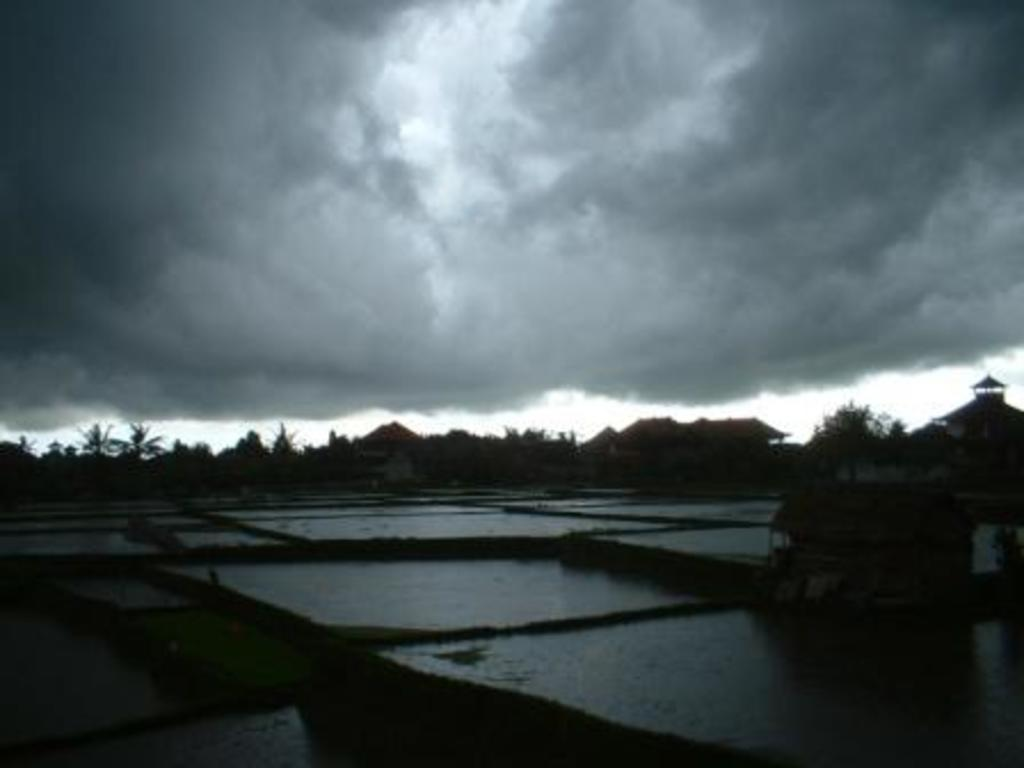What is present in the front of the image? There is water in the front of the image. What can be seen in the image besides the water? There is an object visible in the image. What type of vegetation is visible in the background of the image? There are trees in the background of the image. What type of structures can be seen in the background of the image? There are houses in the background of the image. What is the condition of the sky in the background of the image? The sky is cloudy in the background of the image. How many giraffes are visible in the image? There are no giraffes present in the image. What type of group is shown interacting with the houses in the image? There is no group shown interacting with the houses in the image; only the houses and trees are present. 